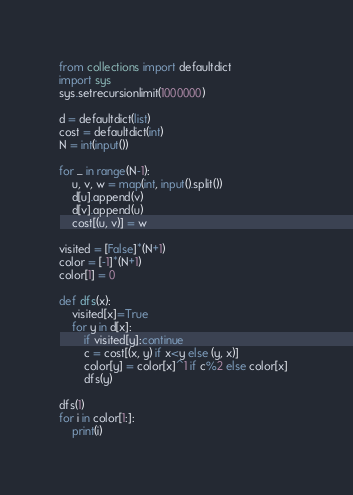<code> <loc_0><loc_0><loc_500><loc_500><_Python_>from collections import defaultdict
import sys
sys.setrecursionlimit(1000000)

d = defaultdict(list)
cost = defaultdict(int)
N = int(input())

for _ in range(N-1):
    u, v, w = map(int, input().split())
    d[u].append(v)
    d[v].append(u)
    cost[(u, v)] = w

visited = [False]*(N+1)
color = [-1]*(N+1)
color[1] = 0

def dfs(x):
    visited[x]=True
    for y in d[x]:
        if visited[y]:continue
        c = cost[(x, y) if x<y else (y, x)]
        color[y] = color[x]^1 if c%2 else color[x]  
        dfs(y)

dfs(1)
for i in color[1:]:
    print(i)</code> 